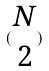<formula> <loc_0><loc_0><loc_500><loc_500>( \begin{matrix} N \\ 2 \end{matrix} )</formula> 